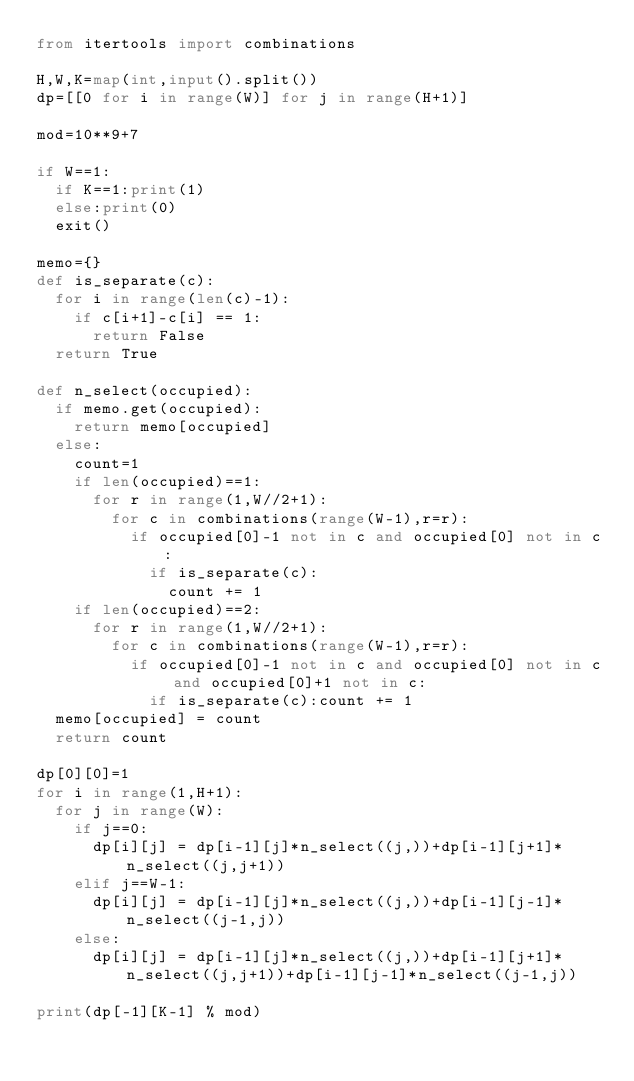<code> <loc_0><loc_0><loc_500><loc_500><_Python_>from itertools import combinations

H,W,K=map(int,input().split())
dp=[[0 for i in range(W)] for j in range(H+1)]

mod=10**9+7

if W==1:
  if K==1:print(1)
  else:print(0)
  exit()

memo={}
def is_separate(c):
  for i in range(len(c)-1):
    if c[i+1]-c[i] == 1:
      return False
  return True

def n_select(occupied):
  if memo.get(occupied):
    return memo[occupied]
  else:
    count=1
    if len(occupied)==1:
      for r in range(1,W//2+1):
        for c in combinations(range(W-1),r=r):
          if occupied[0]-1 not in c and occupied[0] not in c:
            if is_separate(c):
              count += 1
    if len(occupied)==2:
      for r in range(1,W//2+1):
        for c in combinations(range(W-1),r=r):
          if occupied[0]-1 not in c and occupied[0] not in c and occupied[0]+1 not in c:
            if is_separate(c):count += 1
  memo[occupied] = count
  return count

dp[0][0]=1
for i in range(1,H+1):
  for j in range(W):
    if j==0:
      dp[i][j] = dp[i-1][j]*n_select((j,))+dp[i-1][j+1]*n_select((j,j+1))
    elif j==W-1:
      dp[i][j] = dp[i-1][j]*n_select((j,))+dp[i-1][j-1]*n_select((j-1,j))
    else:
      dp[i][j] = dp[i-1][j]*n_select((j,))+dp[i-1][j+1]*n_select((j,j+1))+dp[i-1][j-1]*n_select((j-1,j))

print(dp[-1][K-1] % mod)</code> 